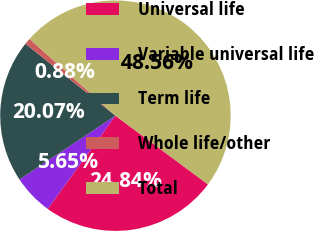Convert chart. <chart><loc_0><loc_0><loc_500><loc_500><pie_chart><fcel>Universal life<fcel>Variable universal life<fcel>Term life<fcel>Whole life/other<fcel>Total<nl><fcel>24.84%<fcel>5.65%<fcel>20.07%<fcel>0.88%<fcel>48.56%<nl></chart> 